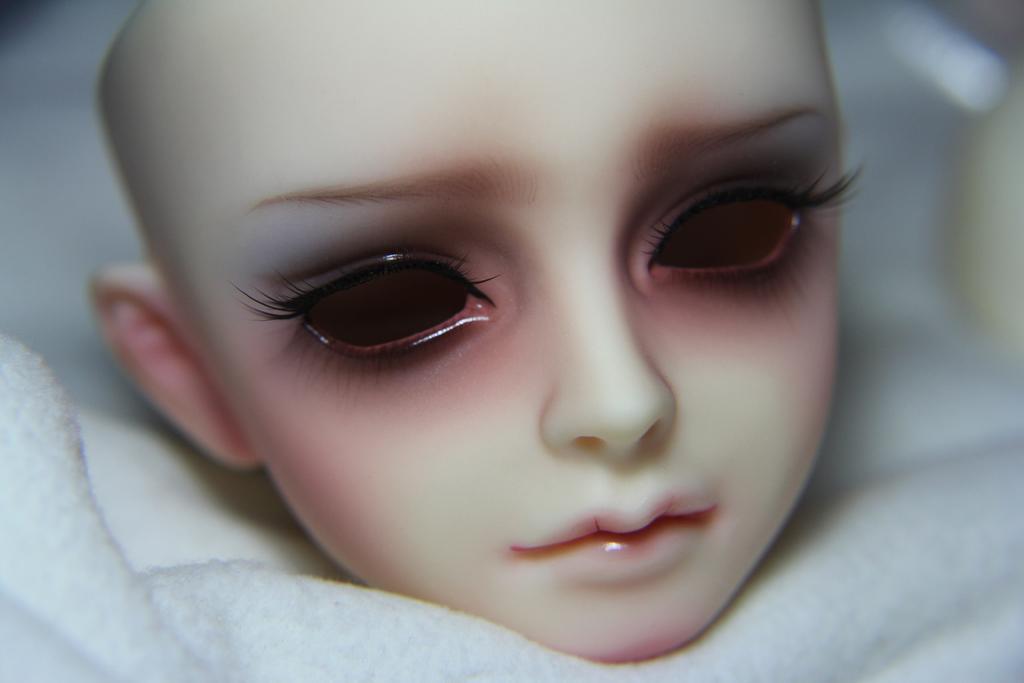Could you give a brief overview of what you see in this image? In this picture I can see there is a doll placed on a white cloth. The backdrop is blurred. 